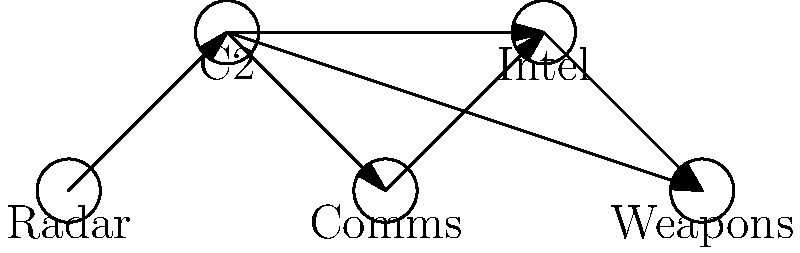Based on the network diagram showing data flow between defense systems, which system appears to be the central hub for information processing and decision-making? What potential vulnerabilities or bottlenecks does this structure present? To answer this question, we need to analyze the network diagram step by step:

1. Identify all systems in the diagram:
   - Radar
   - C2 (Command and Control)
   - Comms (Communications)
   - Intel (Intelligence)
   - Weapons

2. Examine the data flow (arrows) between systems:
   - Radar sends data to C2
   - C2 sends data to Comms, Intel, and Weapons
   - Comms sends data to Intel
   - Intel sends data to Weapons

3. Determine the central hub:
   - C2 (Command and Control) has the most connections (4 in total)
   - C2 receives data from Radar and distributes it to other systems

4. Analyze potential vulnerabilities and bottlenecks:
   a) Single point of failure: If C2 fails, most of the system's functionality would be compromised
   b) Information overload: C2 processes and distributes data from multiple sources, which could lead to delays or errors
   c) Limited redundancy: There are no alternative paths for data flow if C2 is compromised
   d) Potential for cascading failures: A problem in C2 could affect multiple downstream systems

5. Consider the implications for a defense contracting company:
   - Need for robust C2 systems with high reliability and processing capability
   - Importance of backup systems and redundant communication channels
   - Potential for developing distributed command and control architectures to mitigate risks
Answer: C2 (Command and Control) is the central hub. Vulnerabilities include single point of failure, information overload, limited redundancy, and potential for cascading failures. 